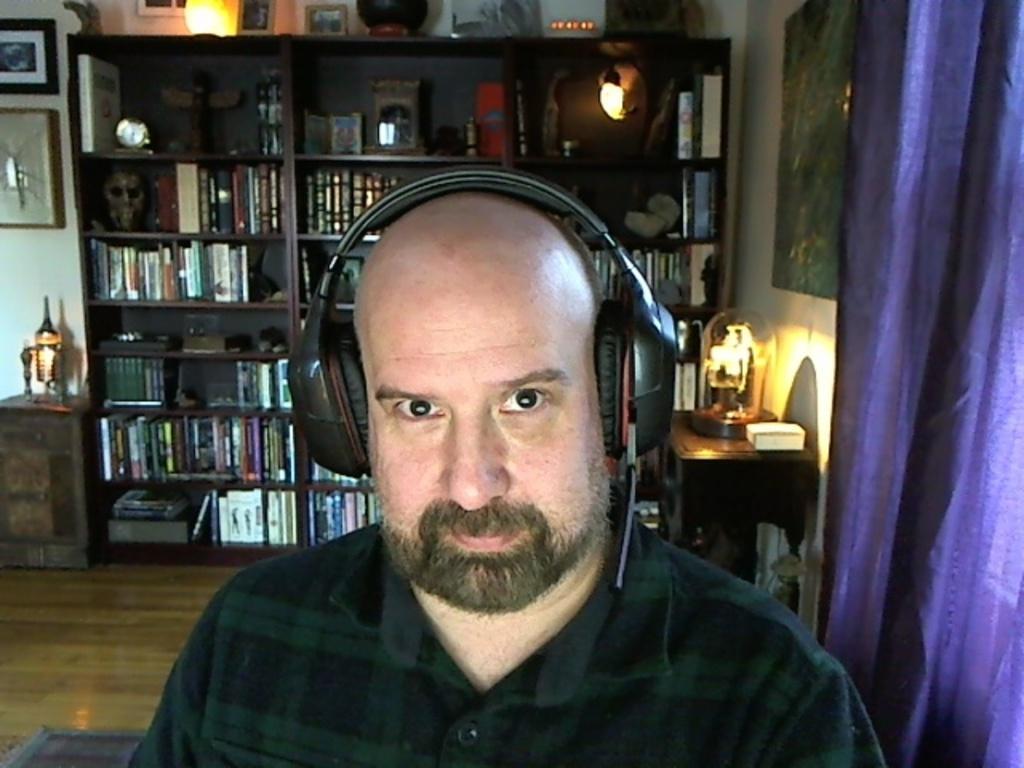Please provide a concise description of this image. In front of the picture, we see a man is wearing the headsets and he is staring at something. On the right side, we see a curtain in violet color. Beside that, we see a table on which a lamp and a white color object are placed. Behind that, we see a wall on which a photo frame is placed. On the left side, we see a table on which a lamp is placed. Behind that, we see a wall on which a clock and a photo frame are placed. In the background, we see a rack in which many books are placed. On top of the rack, we see the photo frames and a lamp are placed. 